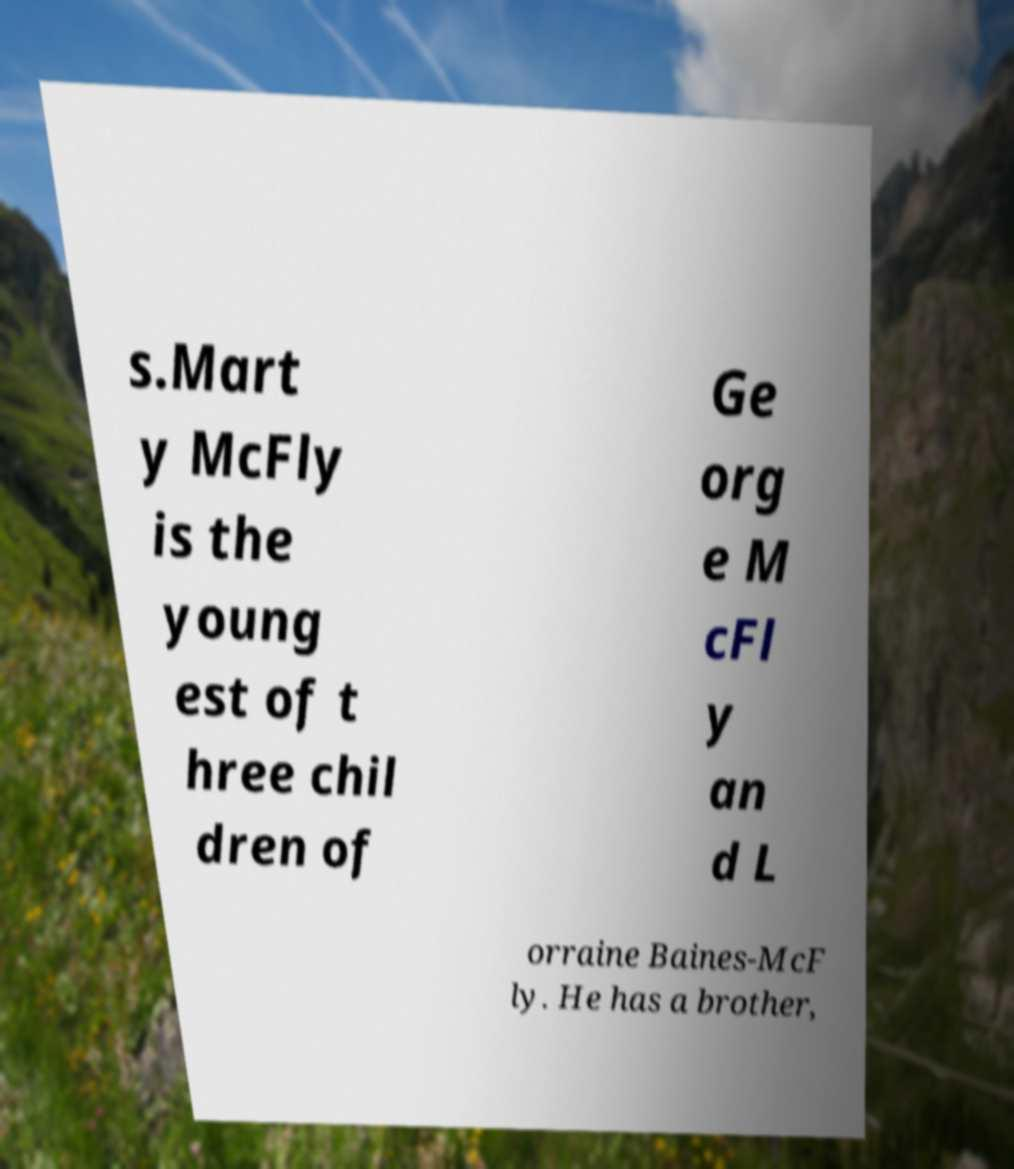Can you read and provide the text displayed in the image?This photo seems to have some interesting text. Can you extract and type it out for me? s.Mart y McFly is the young est of t hree chil dren of Ge org e M cFl y an d L orraine Baines-McF ly. He has a brother, 